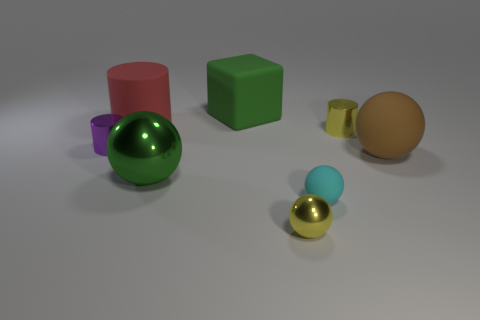There is a large cylinder; is its color the same as the matte thing behind the big red cylinder?
Give a very brief answer. No. There is a green metal thing that is the same shape as the tiny cyan matte object; what size is it?
Offer a very short reply. Large. What is the shape of the rubber object that is both to the left of the large brown matte thing and right of the block?
Provide a short and direct response. Sphere. There is a rubber cylinder; is it the same size as the green object left of the green matte object?
Your response must be concise. Yes. What is the color of the small shiny object that is the same shape as the large brown thing?
Provide a short and direct response. Yellow. Do the metal object that is right of the cyan object and the yellow metallic object in front of the tiny purple cylinder have the same size?
Ensure brevity in your answer.  Yes. Do the brown matte thing and the cyan object have the same shape?
Provide a short and direct response. Yes. What number of objects are either things that are behind the yellow metal ball or big red cylinders?
Your response must be concise. 7. Is there a big brown metal object that has the same shape as the brown rubber object?
Your answer should be compact. No. Are there the same number of large shiny things that are to the left of the tiny purple shiny object and small cylinders?
Keep it short and to the point. No. 